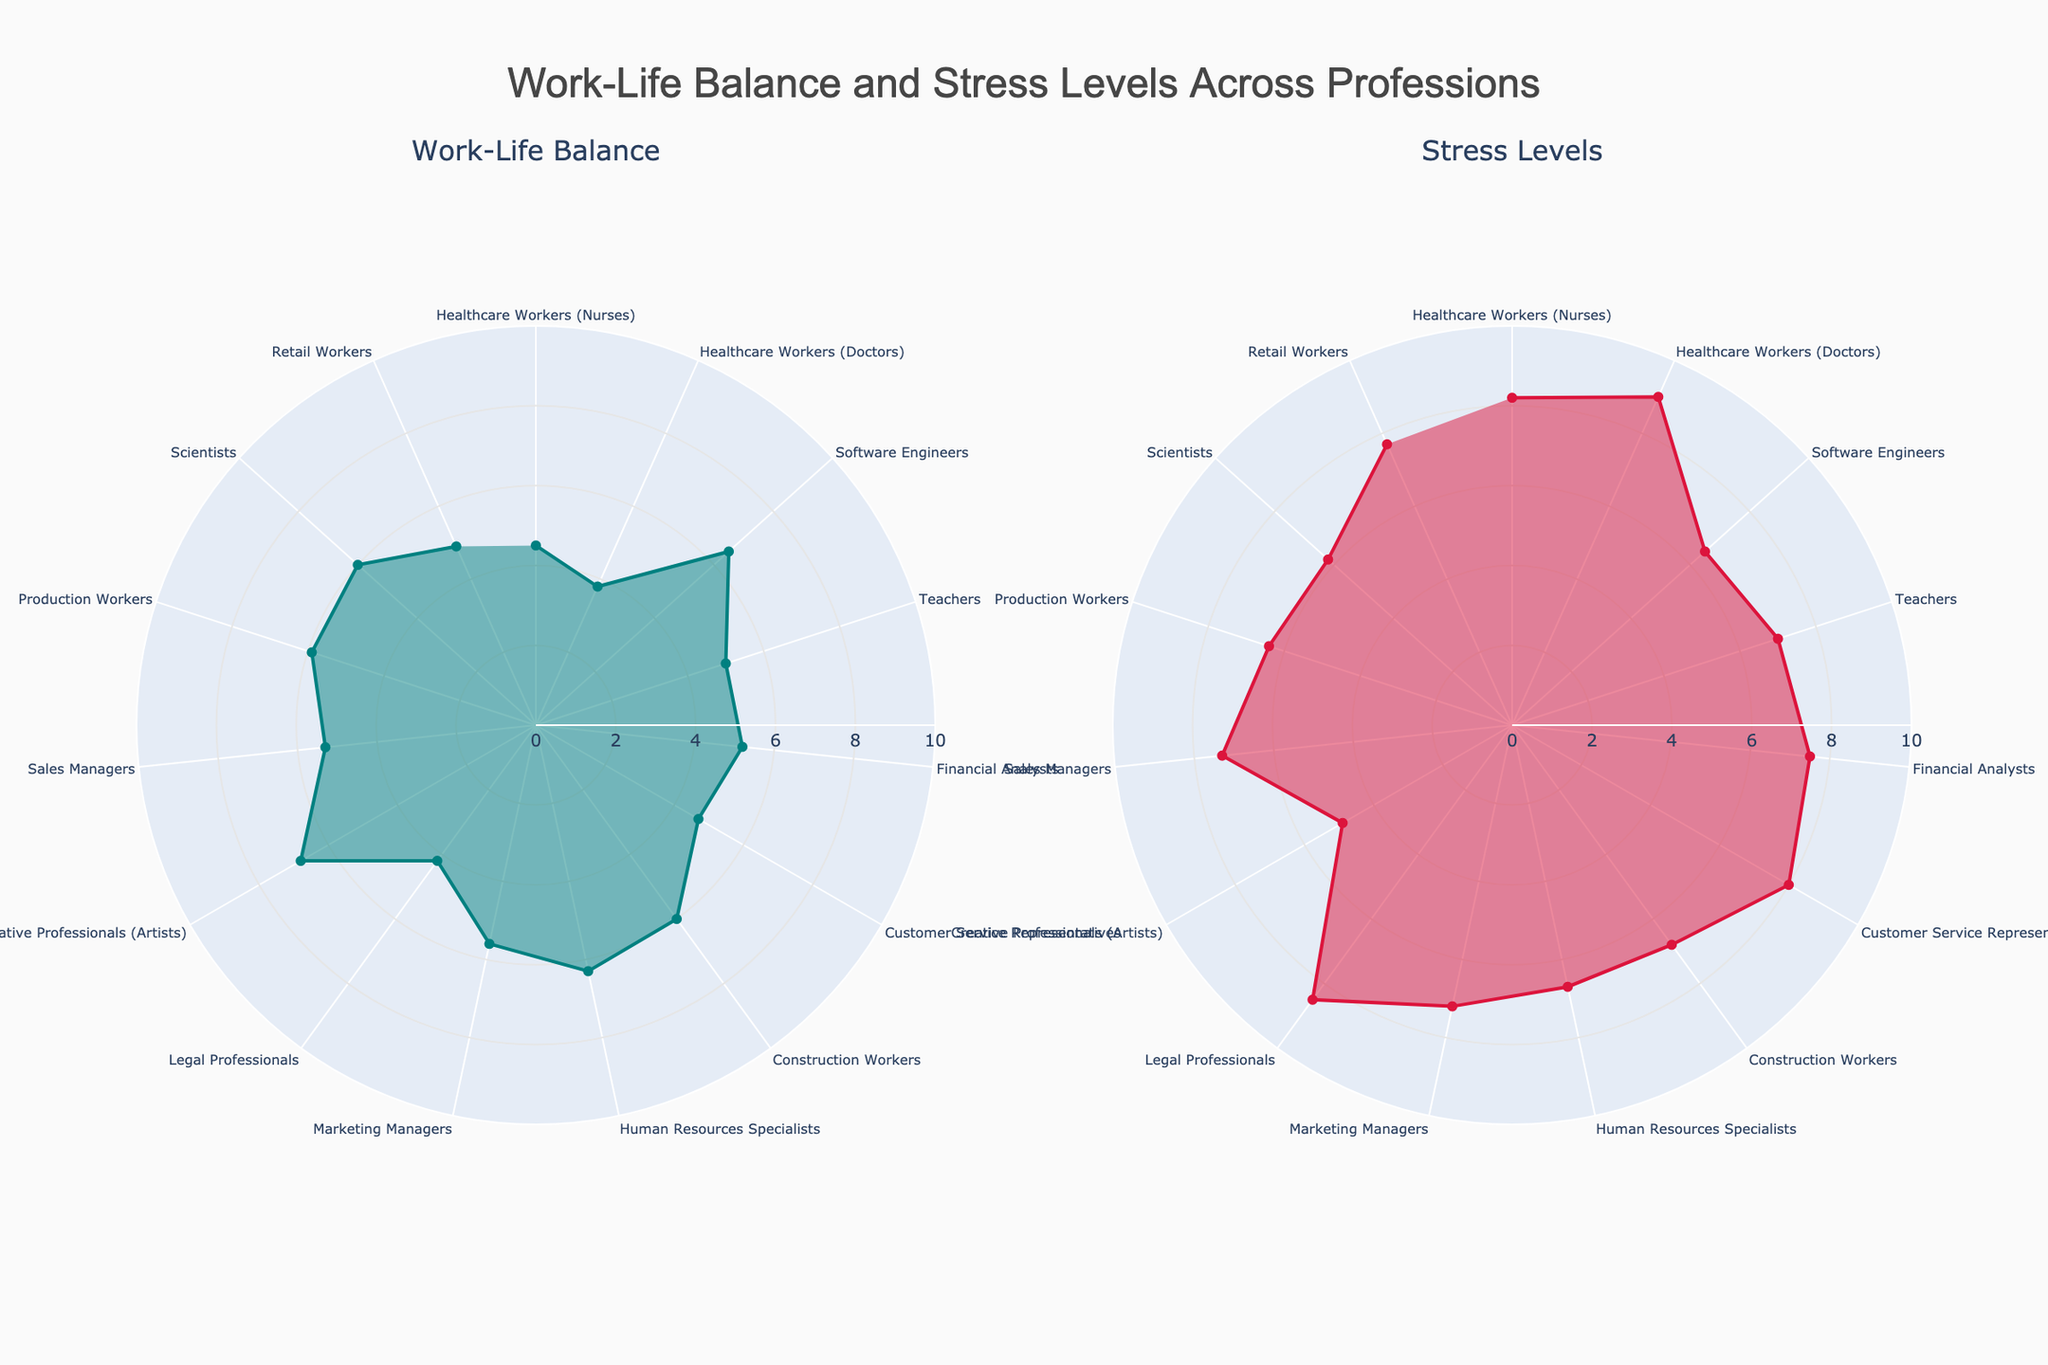What is the title of the figure? The title of the figure is located at the top center of the image, usually in larger and bold font for emphasis. It provides an overview of what the figure represents.
Answer: Work-Life Balance and Stress Levels Across Professions Which profession has the highest work-life balance? Look at the subplot titled "Work-Life Balance" and identify the profession with the highest radial value.
Answer: Creative Professionals (Artists) Which profession has the lowest stress levels? Look at the subplot titled "Stress Levels" and identify the profession with the lowest radial value.
Answer: Creative Professionals (Artists) How do the work-life balance values for Healthcare Workers (Nurses) and Customer Service Representatives compare? Both professionals are plotted on the "Work-Life Balance" subplot. Compare the radial values for each.
Answer: Healthcare Workers (Nurses) have a higher work-life balance than Customer Service Representatives Which profession has the highest stress levels? Refer to the "Stress Levels" subplot and identify the profession with the highest radial value.
Answer: Healthcare Workers (Doctors) What is the average work-life balance for Financial Analysts, Legal Professionals, and Teachers? Look at the "Work-Life Balance" subplot and note the values for Financial Analysts (5.2), Legal Professionals (4.2), and Teachers (5.0). Calculate the average: (5.2 + 4.2 + 5.0) / 3 = 14.4 / 3 = 4.8.
Answer: 4.8 What is the difference in stress levels between Software Engineers and Retail Workers? Refer to the "Stress Levels" subplot and note the values for Software Engineers (6.5) and Retail Workers (7.7). Calculate the difference: 7.7 - 6.5 = 1.2.
Answer: 1.2 Which profession has a better work-life balance: Marketing Managers or Production Workers? Compare the radial values for both professions on the "Work-Life Balance" subplot.
Answer: Production Workers What is the range of work-life balance values in the Creative Professionals (Artists), Computer Engineers, and Teachers? Identify the minimum and maximum work-life balance values among Creative Professionals (Artists) (6.8), Software Engineers (6.5), and Teachers (5.0). Range = maximum value - minimum value = 6.8 - 5.0 = 1.8.
Answer: 1.8 